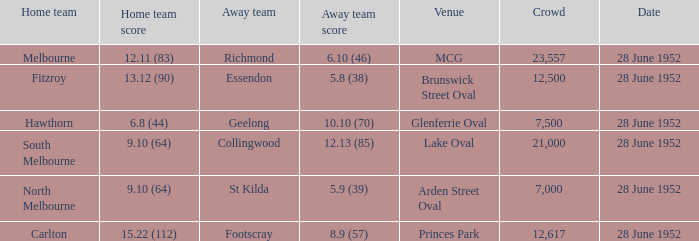What is the away team when north melbourne is at home? St Kilda. 